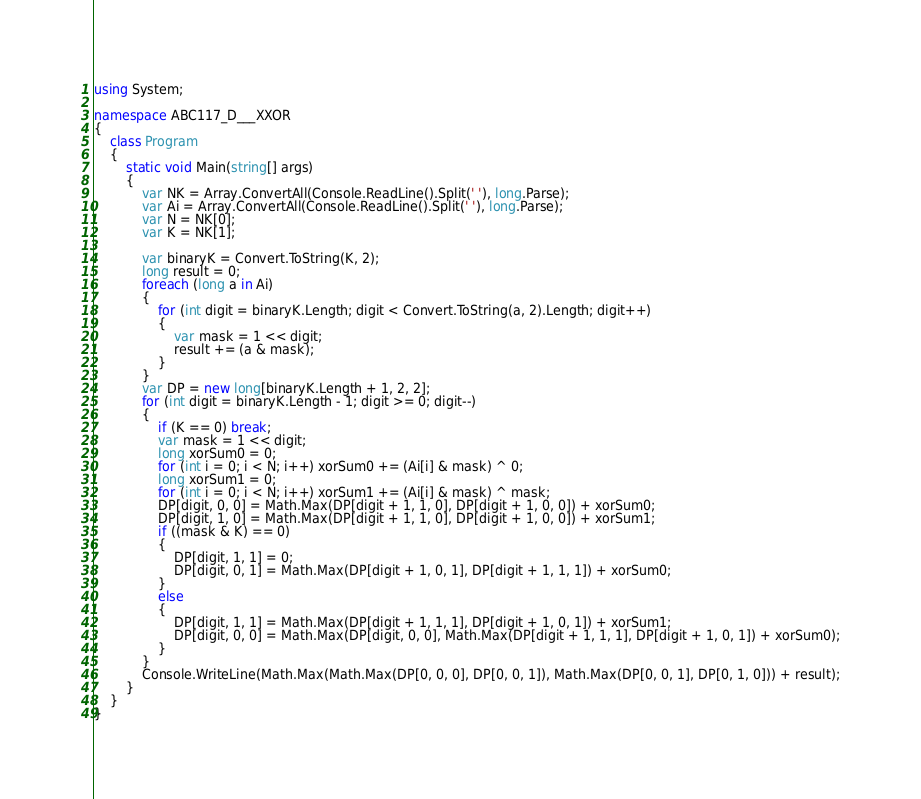Convert code to text. <code><loc_0><loc_0><loc_500><loc_500><_C#_>using System;

namespace ABC117_D___XXOR
{
    class Program
    {
        static void Main(string[] args)
        {
            var NK = Array.ConvertAll(Console.ReadLine().Split(' '), long.Parse);
            var Ai = Array.ConvertAll(Console.ReadLine().Split(' '), long.Parse);
            var N = NK[0];
            var K = NK[1];

            var binaryK = Convert.ToString(K, 2);
            long result = 0;
            foreach (long a in Ai)
            {
                for (int digit = binaryK.Length; digit < Convert.ToString(a, 2).Length; digit++)
                {
                    var mask = 1 << digit;
                    result += (a & mask);
                }
            }
            var DP = new long[binaryK.Length + 1, 2, 2];
            for (int digit = binaryK.Length - 1; digit >= 0; digit--)
            {
                if (K == 0) break;
                var mask = 1 << digit;
                long xorSum0 = 0;
                for (int i = 0; i < N; i++) xorSum0 += (Ai[i] & mask) ^ 0;
                long xorSum1 = 0;
                for (int i = 0; i < N; i++) xorSum1 += (Ai[i] & mask) ^ mask;
                DP[digit, 0, 0] = Math.Max(DP[digit + 1, 1, 0], DP[digit + 1, 0, 0]) + xorSum0;
                DP[digit, 1, 0] = Math.Max(DP[digit + 1, 1, 0], DP[digit + 1, 0, 0]) + xorSum1;
                if ((mask & K) == 0)
                {
                    DP[digit, 1, 1] = 0;
                    DP[digit, 0, 1] = Math.Max(DP[digit + 1, 0, 1], DP[digit + 1, 1, 1]) + xorSum0;
                }
                else
                {
                    DP[digit, 1, 1] = Math.Max(DP[digit + 1, 1, 1], DP[digit + 1, 0, 1]) + xorSum1;
                    DP[digit, 0, 0] = Math.Max(DP[digit, 0, 0], Math.Max(DP[digit + 1, 1, 1], DP[digit + 1, 0, 1]) + xorSum0);
                }
            }
            Console.WriteLine(Math.Max(Math.Max(DP[0, 0, 0], DP[0, 0, 1]), Math.Max(DP[0, 0, 1], DP[0, 1, 0])) + result);
        }
    }
}
</code> 